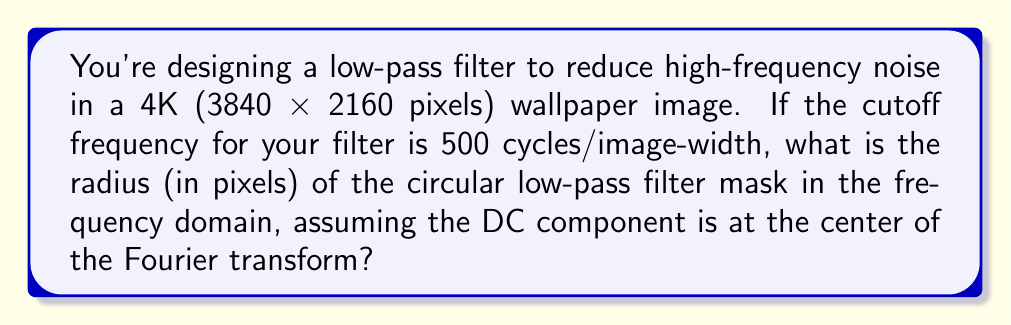Could you help me with this problem? To solve this problem, we need to follow these steps:

1) First, recall that in the frequency domain, the Fourier transform of an image is represented in a 2D plane where the center represents the DC (zero frequency) component, and the distance from the center represents increasing frequencies.

2) The Nyquist frequency (the highest frequency that can be represented in the image) corresponds to half the sampling rate. For a digital image, this is half the number of pixels in each dimension.

3) In this case, the image width is 3840 pixels. So the Nyquist frequency is 1920 cycles/image-width.

4) The cutoff frequency is given as 500 cycles/image-width. We need to find what fraction this is of the Nyquist frequency:

   $$ \frac{\text{Cutoff frequency}}{\text{Nyquist frequency}} = \frac{500}{1920} \approx 0.2604 $$

5) This fraction represents the relative radius of our circular filter in the frequency domain, where a radius of 1 would extend to the corners of the Fourier transform.

6) To find the actual radius in pixels, we need to multiply this fraction by half the width of the Fourier transform. The Fourier transform will have the same dimensions as the original image (3840 x 2160).

7) The radius in pixels is therefore:

   $$ r = 0.2604 \times \frac{3840}{2} \approx 500 \text{ pixels} $$

Thus, the radius of the circular low-pass filter mask in the frequency domain is approximately 500 pixels.
Answer: 500 pixels 